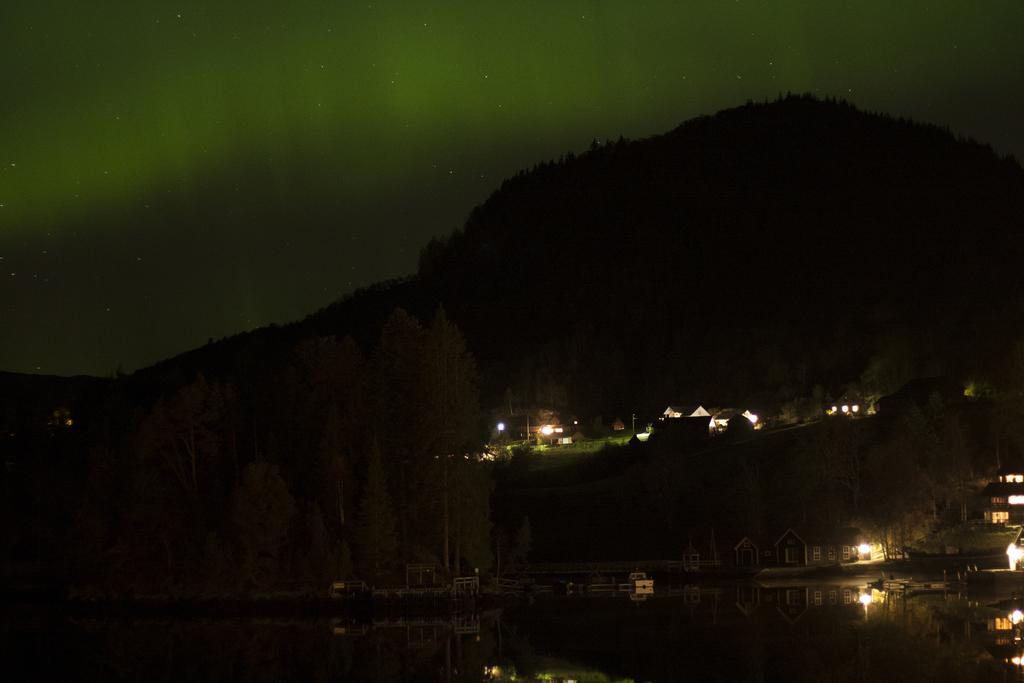What body of water is present in the image? There is a lake in the image in the image. What can be seen behind the lake? There are trees, houses, and mountains behind the lake. Can you describe the landscape surrounding the lake? The lake is surrounded by trees, houses, and mountains. What is visible in the sky at the top of the image? Stars are visible in the sky at the top of the image. Reasoning: Let's think step by step by step in order to produce the conversation. We start by identifying the main subject in the image, which is the lake. Then, we expand the conversation to include other elements that are also visible, such as the trees, houses, mountains, and stars. Each question is designed to elicit a specific detail about the image that is known from the provided facts. Absurd Question/Answer: Where is the sidewalk located in the image? There is no sidewalk present in the image. Can you describe the head of the person in the image? There are no people visible in the image, so it is not possible to describe a person's head. 